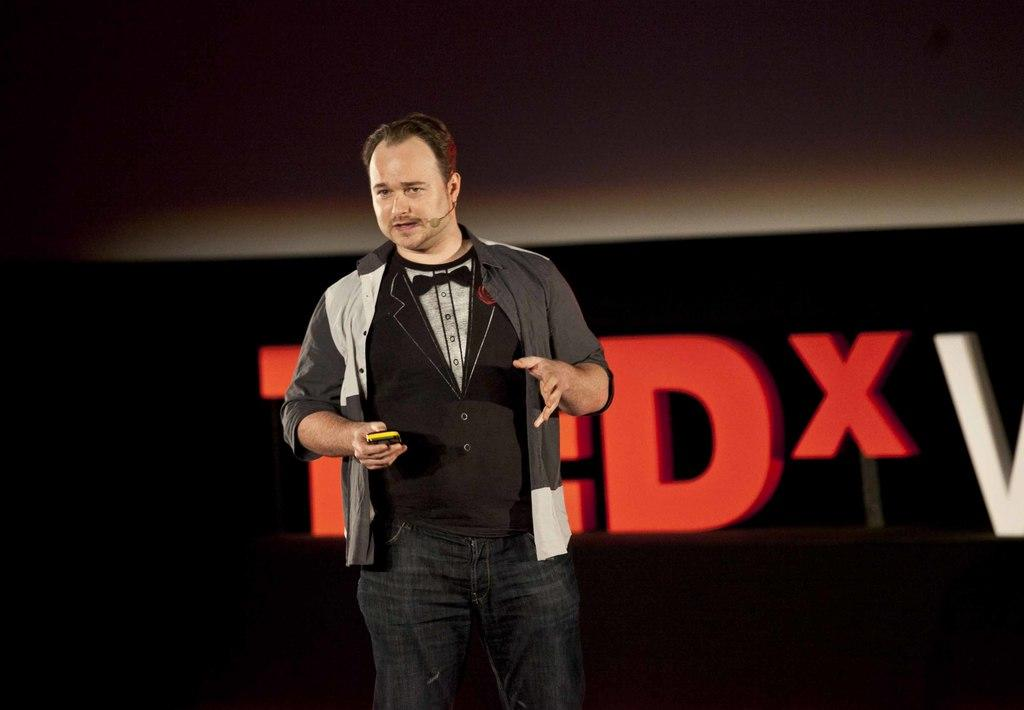What is the main subject of the image? The main subject of the image is a man. What is the man doing in the image? The man is standing in the image. What is the man holding in his hand? The man is holding an object in his hand. Can you describe the man's attire? The man is wearing a microphone, pants, and other types of clothes. What can be seen in the background of the image? There is a background in the image, and a name is visible in the background. What type of pest can be seen causing destruction in the image? There is no pest or destruction present in the image; it features a man standing and holding an object. 